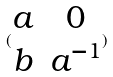Convert formula to latex. <formula><loc_0><loc_0><loc_500><loc_500>( \begin{matrix} a & 0 \\ b & a ^ { - 1 } \end{matrix} )</formula> 